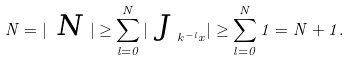Convert formula to latex. <formula><loc_0><loc_0><loc_500><loc_500>N = | \emph { N } | \geq \sum _ { l = 0 } ^ { N } | \emph { J } _ { k ^ { - l } x } | \geq \sum _ { l = 0 } ^ { N } 1 = N + 1 .</formula> 